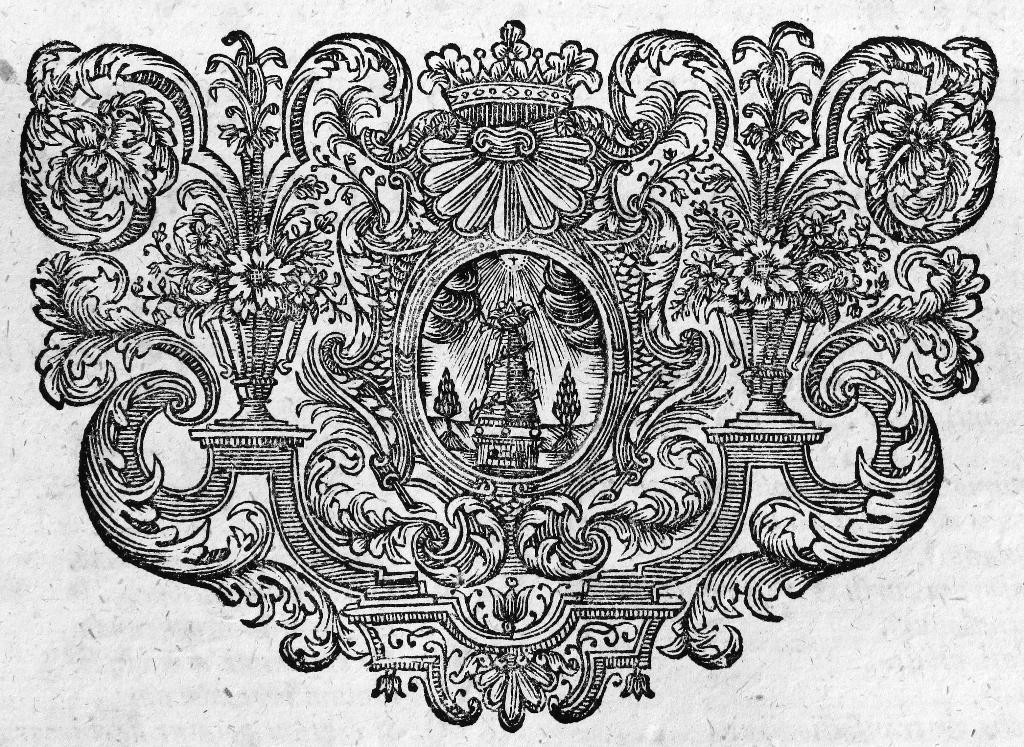Could you give a brief overview of what you see in this image? In this picture on the paper. In the center we can see the plants and flowers. 